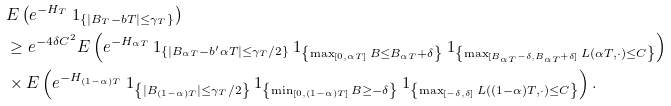Convert formula to latex. <formula><loc_0><loc_0><loc_500><loc_500>& E \left ( e ^ { - H _ { T } } \ 1 _ { \{ | B _ { T } - b T | \leq \gamma _ { T } \} } \right ) \\ & \geq e ^ { - 4 \delta C ^ { 2 } } E \left ( e ^ { - H _ { \alpha T } } \ 1 _ { \{ | B _ { \alpha T } - b ^ { \prime } \alpha T | \leq \gamma _ { T } / 2 \} } \ 1 _ { \left \{ \max _ { [ 0 , \alpha T ] } B \leq B _ { \alpha T } + \delta \right \} } \ 1 _ { \left \{ \max _ { [ B _ { \alpha T } - \delta , B _ { \alpha T } + \delta ] } L ( \alpha T , \cdot ) \leq C \right \} } \right ) \\ & \times E \left ( e ^ { - H _ { ( 1 - \alpha ) T } } \ 1 _ { \left \{ | B _ { ( 1 - \alpha ) T } | \leq \gamma _ { T } / 2 \right \} } \ 1 _ { \left \{ \min _ { [ 0 , ( 1 - \alpha ) T ] } B \geq - \delta \right \} } \ 1 _ { \left \{ \max _ { [ - \delta , \delta ] } L ( ( 1 - \alpha ) T , \cdot ) \leq C \right \} } \right ) .</formula> 